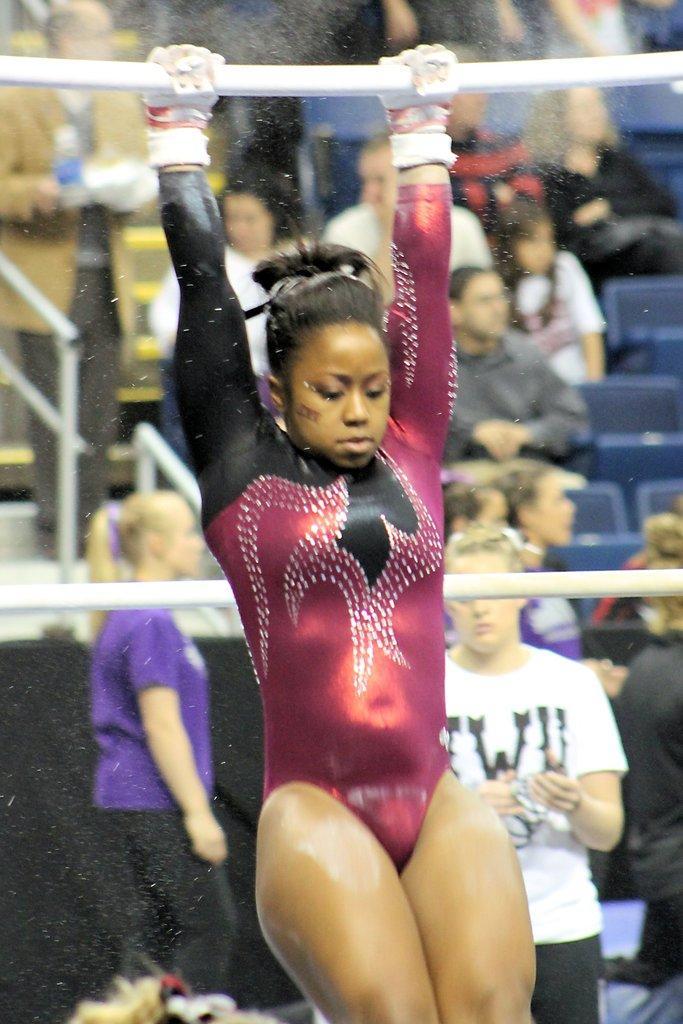Could you give a brief overview of what you see in this image? In this picture we can see a woman is holding and iron rod and behind the woman there is another rod. Some people are standing and some people are sitting on chairs. On the left side of the people there are iron grilles. 